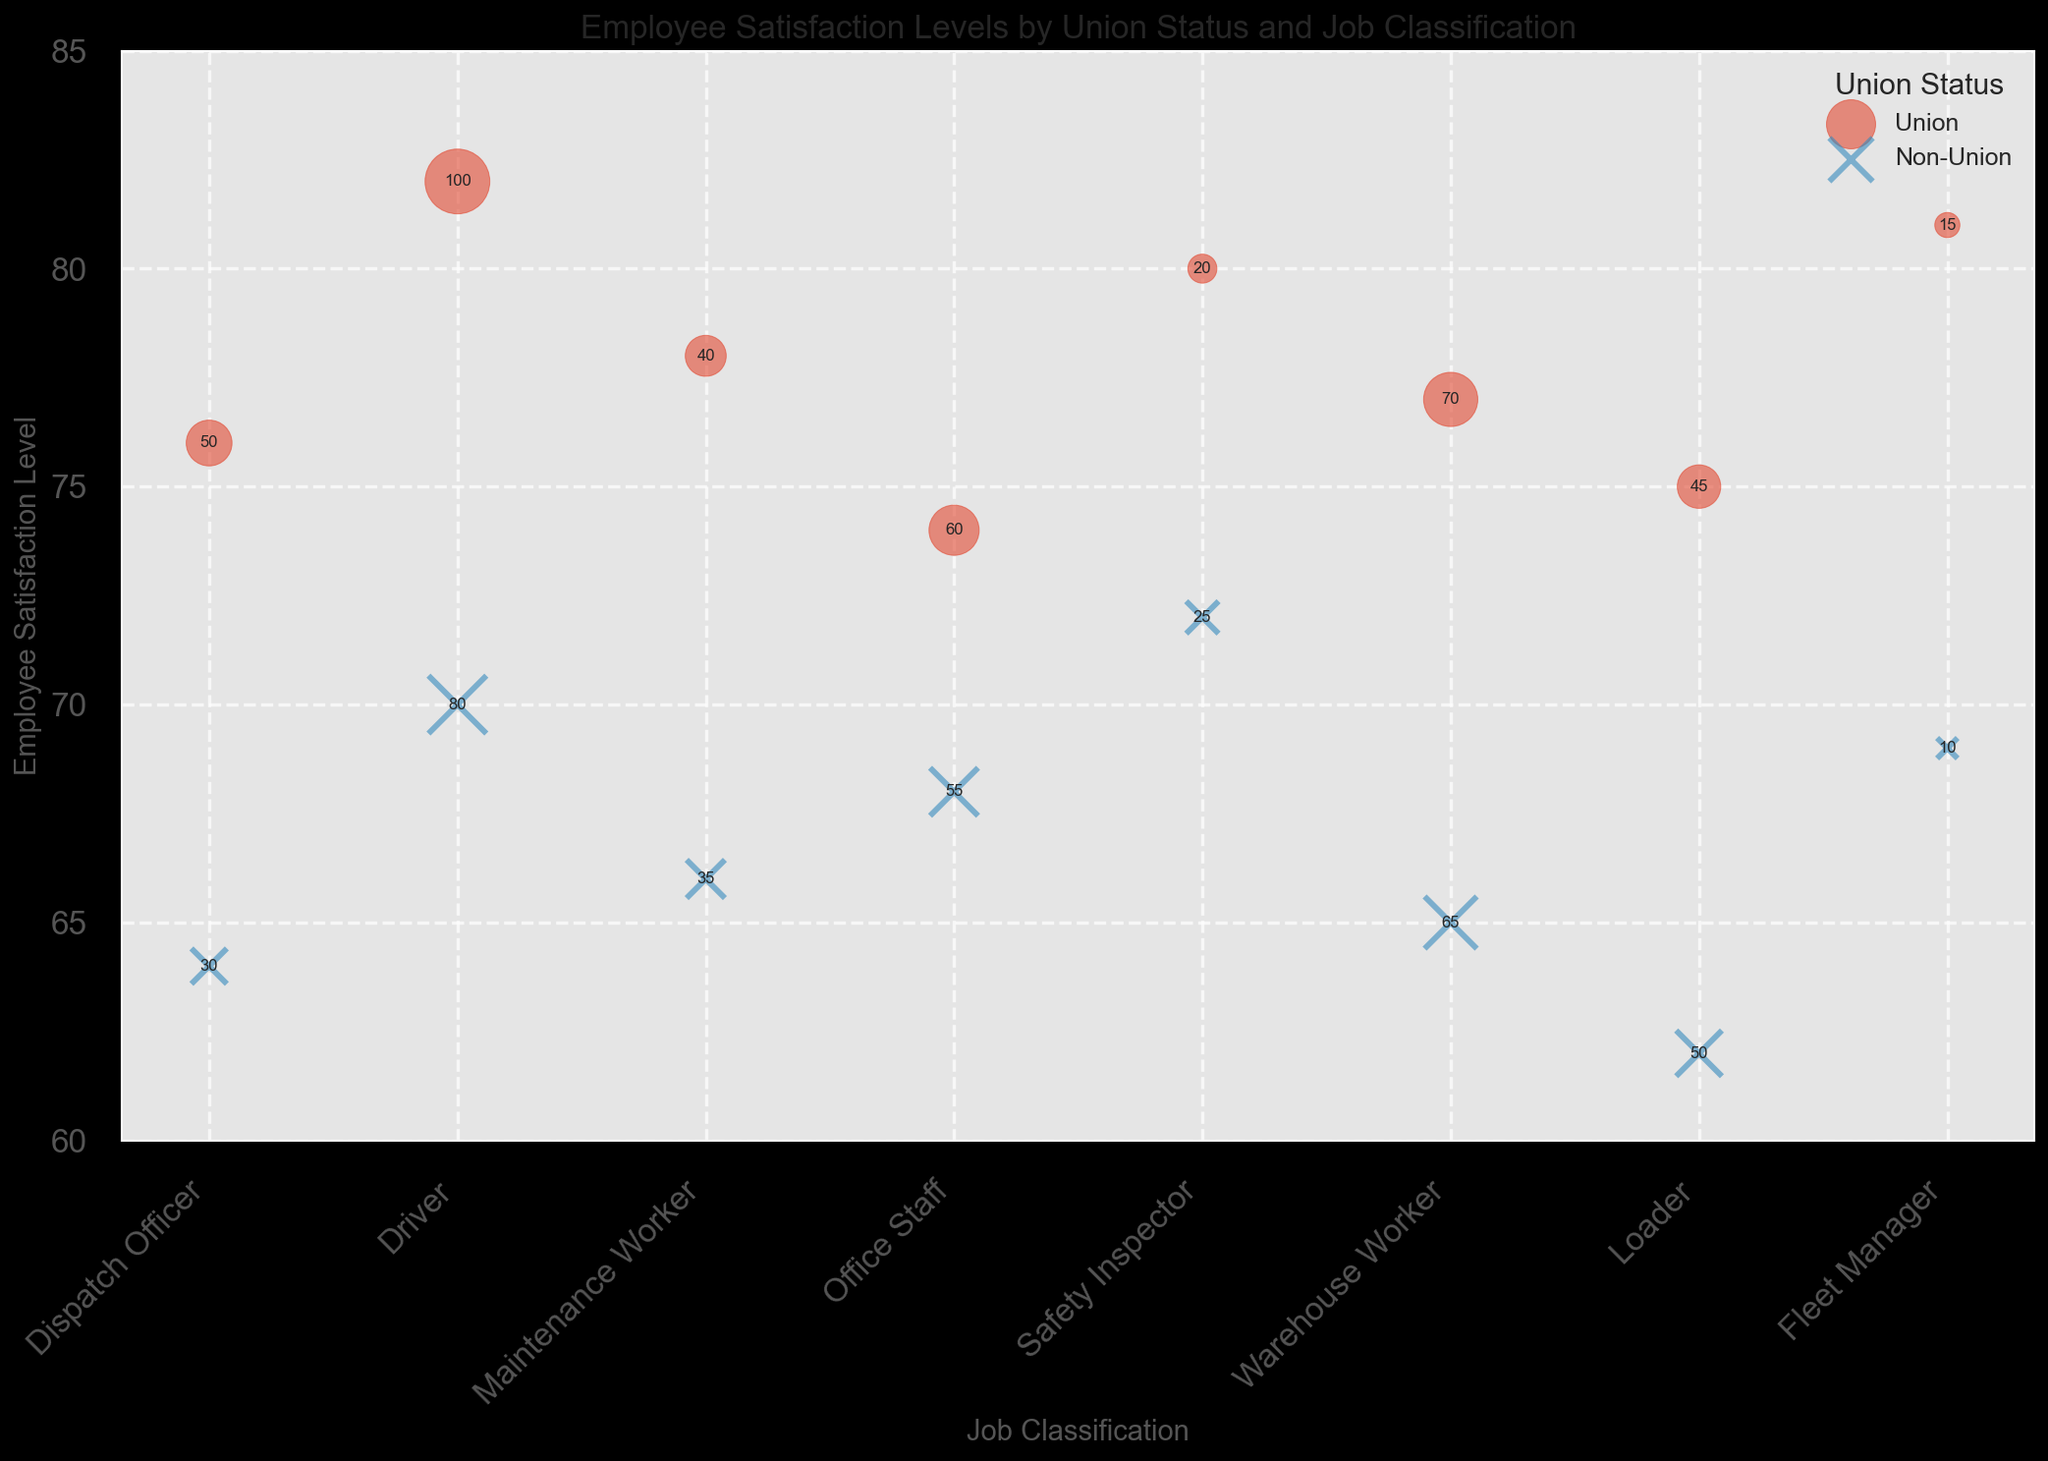Which Union Status has a higher average employee satisfaction level? To calculate the average employee satisfaction level for both Union and Non-Union employees, sum the satisfaction levels per Union Status, then divide by the number of occurrences. Union: (76 + 82 + 78 + 74 + 80 + 77 + 75 + 81) / 8 = 78.875, Non-Union: (64 + 70 + 66 + 68 + 72 + 65 + 62 + 69) / 8 = 67.
Answer: Union Which job classification has the largest difference in employee satisfaction levels between Union and Non-Union employees? The difference in satisfaction levels can be calculated by subtracting the Non-Union satisfaction level from the Union satisfaction level for each job classification. The differences are: Dispatch Officer (12), Driver (12), Maintenance Worker (12), Office Staff (6), Safety Inspector (8), Warehouse Worker (12), Loader (13), Fleet Manager (12). The largest is Loader with a difference of 13.
Answer: Loader Which job classification & union status combination has the highest employee satisfaction level? From the figure, look at the highest satisfaction levels. Among all the points, Driver (Union) has the highest satisfaction level of 82.
Answer: Driver (Union) Which union status has more job classifications with a satisfaction level below 70? Count the number of job classifications for Union and Non-Union that have satisfaction levels below 70. Union: 0 job classifications. Non-Union: Dispatch Officer (64), Maintenance Worker (66), Warehouse Worker (65), Loader (62), Fleet Manager (69). Non-Union has 5 job classifications below 70.
Answer: Non-Union Are there any job classifications where Union and Non-Union employees have the same number of employees? Compare the number of employees for Union and Non-Union statuses within the same job classification. Only Warehouse Worker has the same number of employees for both Union and Non-Union, which is 65.
Answer: Warehouse Worker Visualizing the bubble sizes, which job classification has the largest number of employees? The largest bubble size indicates the highest number of employees. For Drivers (Union) with a bubble size of 1000 (100 employees * 10), it's the largest.
Answer: Driver (Union) How many job classifications have a satisfaction level between 65 and 75 for Non-Union employees? Count the Non-Union entries with satisfaction levels from 65 to 75. They are: Driver (70), Maintenance Worker (66), Office Staff (68), Safety Inspector (72), Warehouse Worker (65), Fleet Manager (69). There are 6 such job classifications.
Answer: 6 Does the "Safety Inspector" job classification have higher satisfaction levels for Union or Non-Union employees? Compare the satisfaction levels for Safety Inspector. Union employees have a satisfaction level of 80, while Non-Union employees have a satisfaction level of 72. Union is higher.
Answer: Union Among Union employees, which job classification has the lowest satisfaction level? For Union employee satisfaction levels, the lowest value is determined by looking at the smallest satisfaction number. Office Staff has the lowest satisfaction level at 74.
Answer: Office Staff 